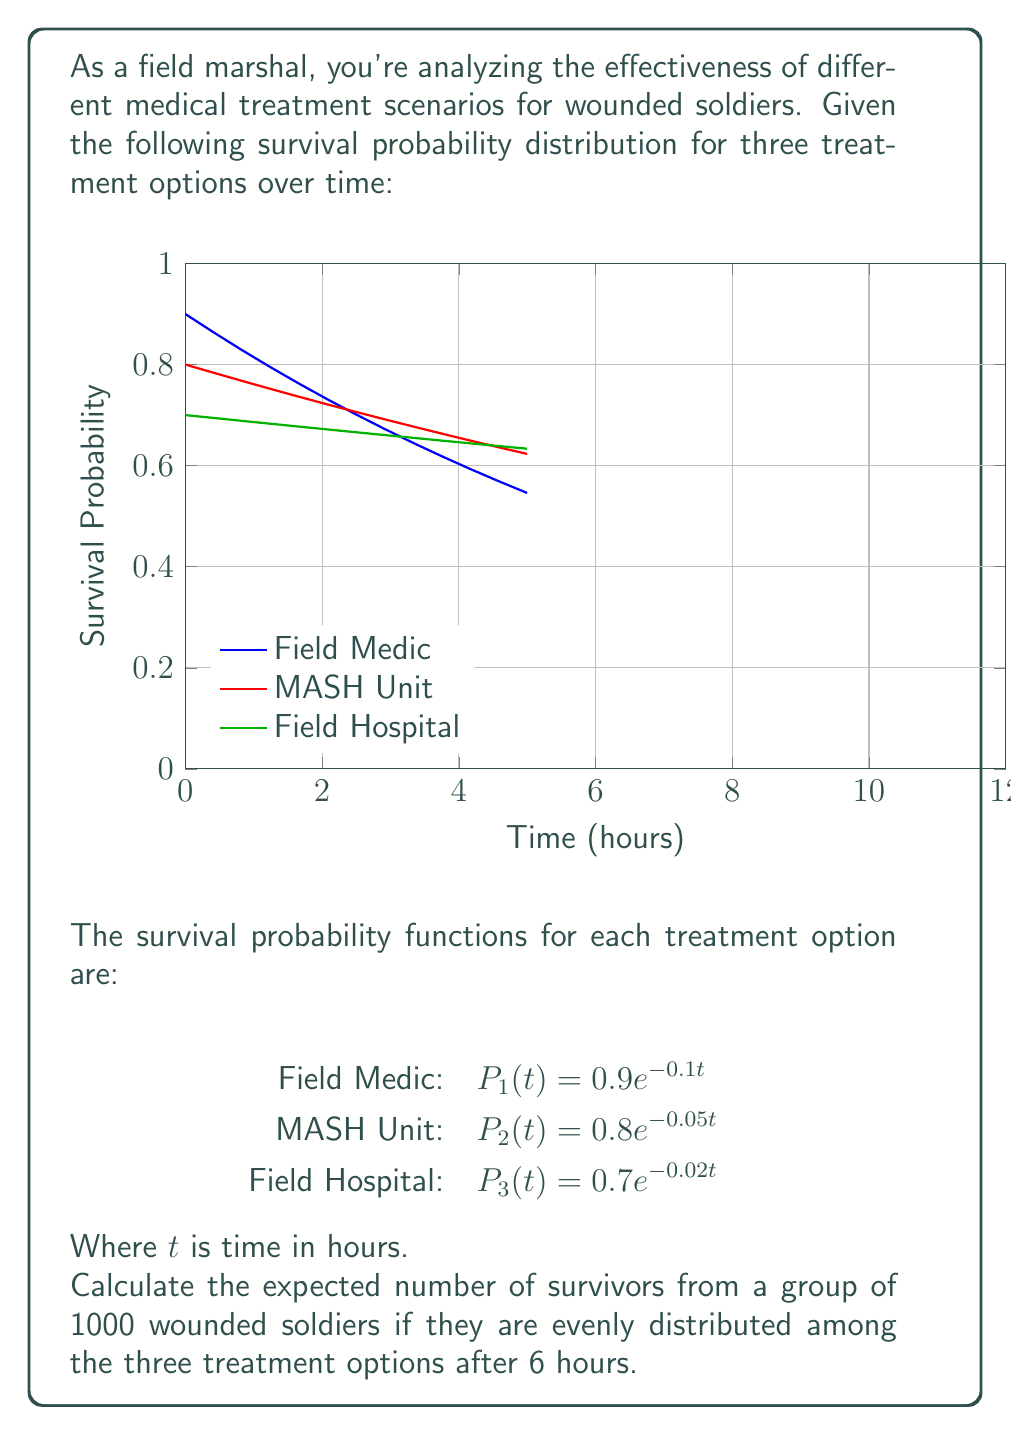Can you solve this math problem? Let's approach this step-by-step:

1) First, we need to calculate the survival probability for each treatment option after 6 hours:

   For Field Medic: $P_1(6) = 0.9e^{-0.1(6)} = 0.9e^{-0.6} \approx 0.4966$
   For MASH Unit: $P_2(6) = 0.8e^{-0.05(6)} = 0.8e^{-0.3} \approx 0.5921$
   For Field Hospital: $P_3(6) = 0.7e^{-0.02(6)} = 0.7e^{-0.12} \approx 0.6225$

2) Since the soldiers are evenly distributed, each treatment option will have 1000/3 ≈ 333.33 soldiers.

3) Now, we calculate the expected number of survivors for each option:

   Field Medic: $333.33 \times 0.4966 \approx 165.53$
   MASH Unit: $333.33 \times 0.5921 \approx 197.36$
   Field Hospital: $333.33 \times 0.6225 \approx 207.50$

4) The total expected number of survivors is the sum of these:

   $165.53 + 197.36 + 207.50 = 570.39$

5) Since we can't have fractional survivors, we round to the nearest whole number: 570.
Answer: 570 survivors 